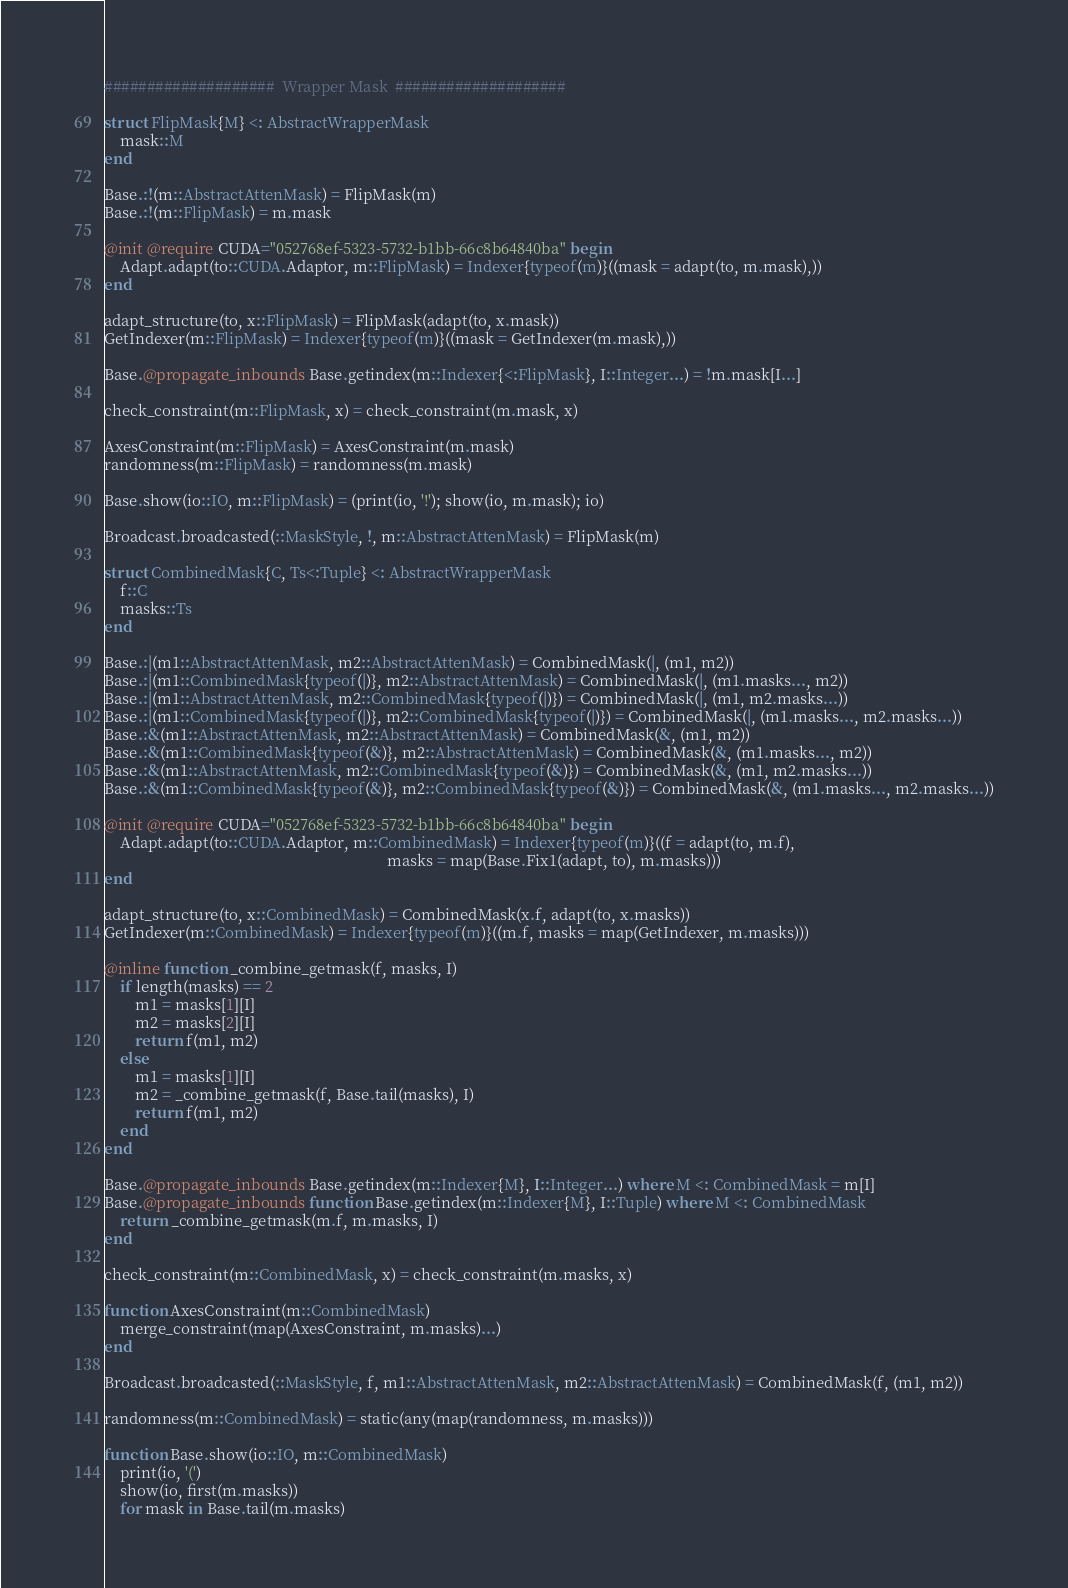Convert code to text. <code><loc_0><loc_0><loc_500><loc_500><_Julia_>####################  Wrapper Mask  ####################

struct FlipMask{M} <: AbstractWrapperMask
    mask::M
end

Base.:!(m::AbstractAttenMask) = FlipMask(m)
Base.:!(m::FlipMask) = m.mask

@init @require CUDA="052768ef-5323-5732-b1bb-66c8b64840ba" begin
    Adapt.adapt(to::CUDA.Adaptor, m::FlipMask) = Indexer{typeof(m)}((mask = adapt(to, m.mask),))
end

adapt_structure(to, x::FlipMask) = FlipMask(adapt(to, x.mask))
GetIndexer(m::FlipMask) = Indexer{typeof(m)}((mask = GetIndexer(m.mask),))

Base.@propagate_inbounds Base.getindex(m::Indexer{<:FlipMask}, I::Integer...) = !m.mask[I...]

check_constraint(m::FlipMask, x) = check_constraint(m.mask, x)

AxesConstraint(m::FlipMask) = AxesConstraint(m.mask)
randomness(m::FlipMask) = randomness(m.mask)

Base.show(io::IO, m::FlipMask) = (print(io, '!'); show(io, m.mask); io)

Broadcast.broadcasted(::MaskStyle, !, m::AbstractAttenMask) = FlipMask(m)

struct CombinedMask{C, Ts<:Tuple} <: AbstractWrapperMask
    f::C
    masks::Ts
end

Base.:|(m1::AbstractAttenMask, m2::AbstractAttenMask) = CombinedMask(|, (m1, m2))
Base.:|(m1::CombinedMask{typeof(|)}, m2::AbstractAttenMask) = CombinedMask(|, (m1.masks..., m2))
Base.:|(m1::AbstractAttenMask, m2::CombinedMask{typeof(|)}) = CombinedMask(|, (m1, m2.masks...))
Base.:|(m1::CombinedMask{typeof(|)}, m2::CombinedMask{typeof(|)}) = CombinedMask(|, (m1.masks..., m2.masks...))
Base.:&(m1::AbstractAttenMask, m2::AbstractAttenMask) = CombinedMask(&, (m1, m2))
Base.:&(m1::CombinedMask{typeof(&)}, m2::AbstractAttenMask) = CombinedMask(&, (m1.masks..., m2))
Base.:&(m1::AbstractAttenMask, m2::CombinedMask{typeof(&)}) = CombinedMask(&, (m1, m2.masks...))
Base.:&(m1::CombinedMask{typeof(&)}, m2::CombinedMask{typeof(&)}) = CombinedMask(&, (m1.masks..., m2.masks...))

@init @require CUDA="052768ef-5323-5732-b1bb-66c8b64840ba" begin
    Adapt.adapt(to::CUDA.Adaptor, m::CombinedMask) = Indexer{typeof(m)}((f = adapt(to, m.f),
                                                                         masks = map(Base.Fix1(adapt, to), m.masks)))
end

adapt_structure(to, x::CombinedMask) = CombinedMask(x.f, adapt(to, x.masks))
GetIndexer(m::CombinedMask) = Indexer{typeof(m)}((m.f, masks = map(GetIndexer, m.masks)))

@inline function _combine_getmask(f, masks, I)
    if length(masks) == 2
        m1 = masks[1][I]
        m2 = masks[2][I]
        return f(m1, m2)
    else
        m1 = masks[1][I]
        m2 = _combine_getmask(f, Base.tail(masks), I)
        return f(m1, m2)
    end
end

Base.@propagate_inbounds Base.getindex(m::Indexer{M}, I::Integer...) where M <: CombinedMask = m[I]
Base.@propagate_inbounds function Base.getindex(m::Indexer{M}, I::Tuple) where M <: CombinedMask
    return _combine_getmask(m.f, m.masks, I)
end

check_constraint(m::CombinedMask, x) = check_constraint(m.masks, x)

function AxesConstraint(m::CombinedMask)
    merge_constraint(map(AxesConstraint, m.masks)...)
end

Broadcast.broadcasted(::MaskStyle, f, m1::AbstractAttenMask, m2::AbstractAttenMask) = CombinedMask(f, (m1, m2))

randomness(m::CombinedMask) = static(any(map(randomness, m.masks)))

function Base.show(io::IO, m::CombinedMask)
    print(io, '(')
    show(io, first(m.masks))
    for mask in Base.tail(m.masks)</code> 